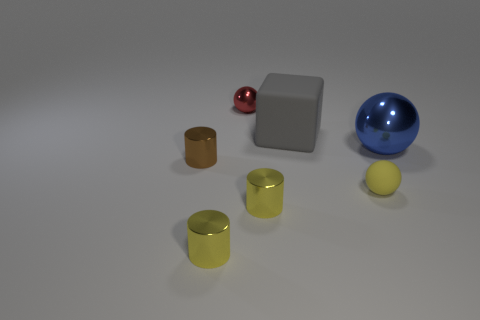Add 2 rubber spheres. How many objects exist? 9 Subtract all cylinders. How many objects are left? 4 Add 6 big metal objects. How many big metal objects are left? 7 Add 3 big spheres. How many big spheres exist? 4 Subtract 0 cyan cylinders. How many objects are left? 7 Subtract all blue rubber things. Subtract all cubes. How many objects are left? 6 